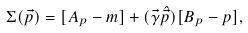Convert formula to latex. <formula><loc_0><loc_0><loc_500><loc_500>\Sigma ( \vec { p } ) = [ A _ { p } - m ] + ( \vec { \gamma } \hat { \vec { p } } ) [ B _ { p } - p ] ,</formula> 